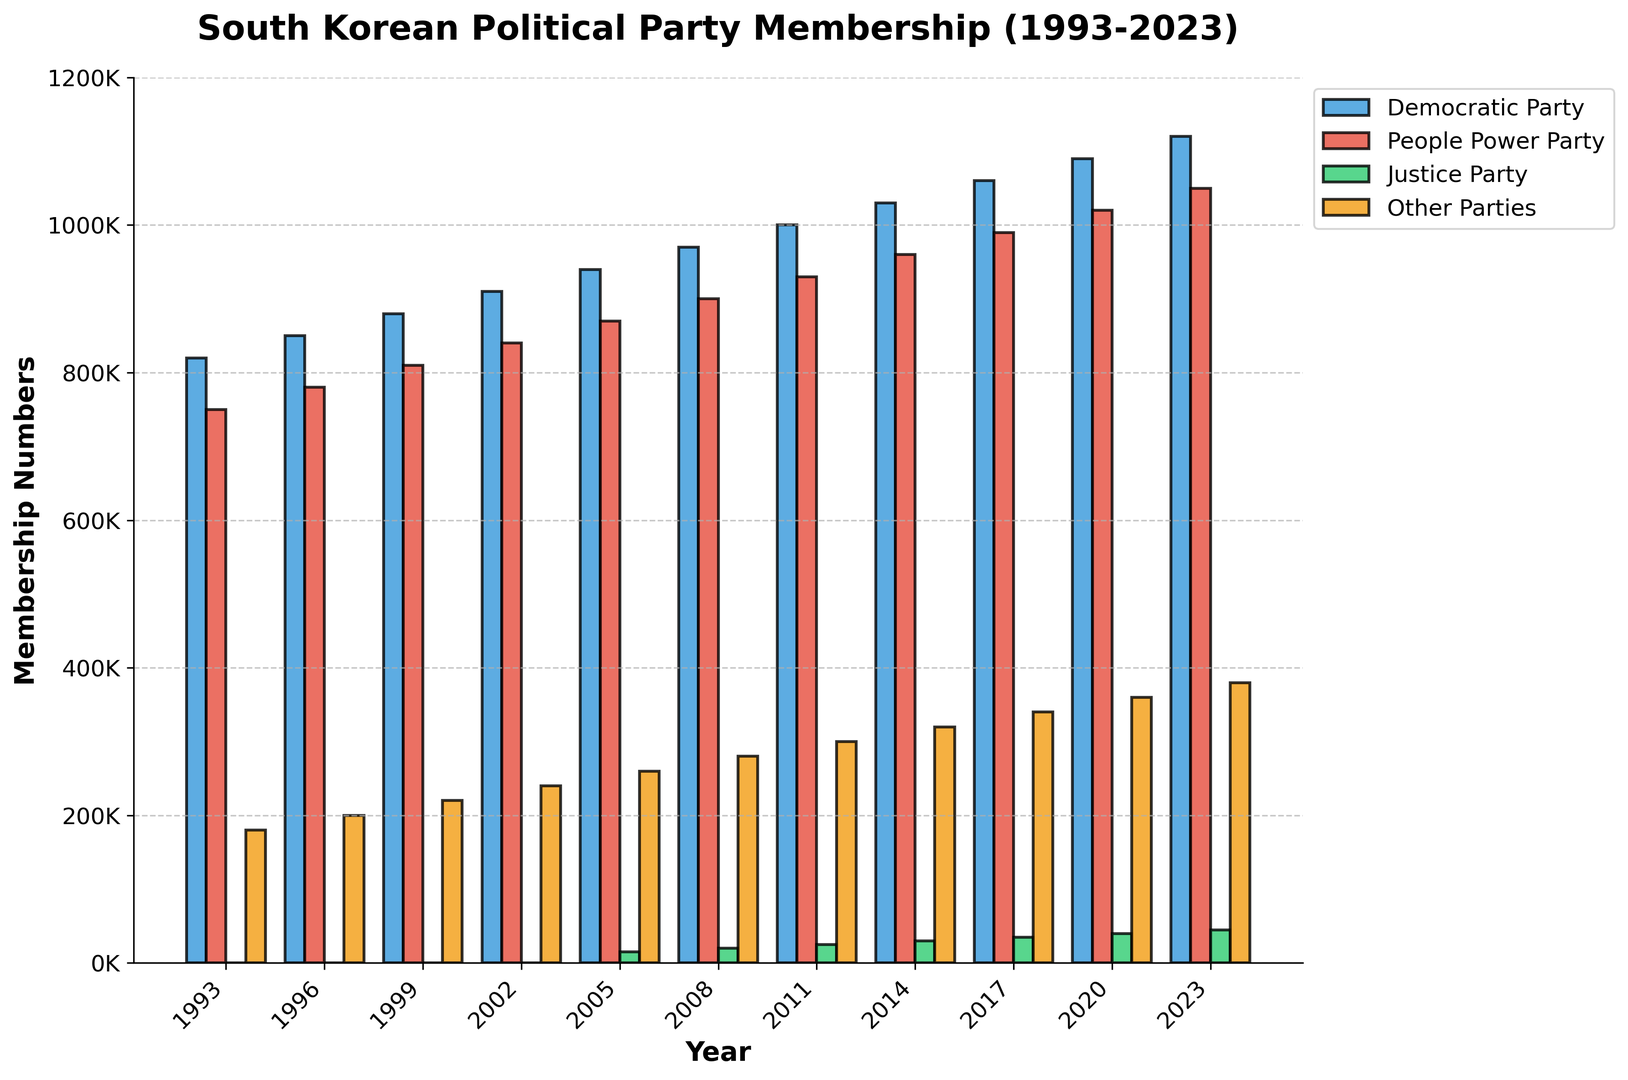What is the total membership of the Democratic Party in 2023? Look at the bar representing the Democratic Party for the year 2023 and read the value directly.
Answer: 1,120,000 Between which two years did the Democratic Party experience the most significant increase in membership? Compare the differences in membership between consecutive years. Identify the two years with the highest difference: 2023 (1,120,000) - 2020 (1,090,000) = 30,000.
Answer: 2020 and 2023 How much more was the membership of the People Power Party than the Justice Party in 2023? Read the values for the People Power Party (1,050,000) and the Justice Party (45,000) for 2023 and subtract the smaller from the larger: 1,050,000 - 45,000 = 1,005,000.
Answer: 1,005,000 Which party had the lowest membership in the year 2005? Compare the bars for each party in 2005 and identify the shortest one, which represents the Justice Party with 15,000.
Answer: Justice Party What is the average membership of the Justice Party over the years it existed (2005-2023)? Add membership values for the Justice Party from 2005 to 2023, then divide by the number of years (6 values): (15,000 + 20,000 + 25,000 + 30,000 + 35,000 + 40,000 + 45,000) / 7 = 210,000 / 7 = 30,000.
Answer: 30,000 By how much did the membership of the Other Parties increase from 1993 to 2023? Subtract the membership of Other Parties in 1993 (180,000) from that in 2023 (380,000): 380,000 - 180,000 = 200,000.
Answer: 200,000 Over the entire period, did the Democratic Party or the People Power Party see a greater increase in membership? Calculate the difference for both parties: Democratic Party: 1,120,000 (2023) - 820,000 (1993) = 300,000; People Power Party: 1,050,000 (2023) - 750,000 (1993) = 300,000.
Answer: Equal Which year had the highest combined membership across all parties? Add the memberships for all parties each year and find the highest total: In 2023, (1,120,000 + 1,050,000 + 45,000 + 380,000 = 2,595,000).
Answer: 2023 What is the overall trend in membership for the Justice Party from 2005 to 2023? The Justice Party membership increased gradually every year from 15,000 in 2005 to 45,000 in 2023.
Answer: Increasing In which year did the Other Parties' membership first exceed 300,000? Review the bars for Other Parties and find when it first exceeded 300,000, which is in 2011 (300,000).
Answer: 2011 